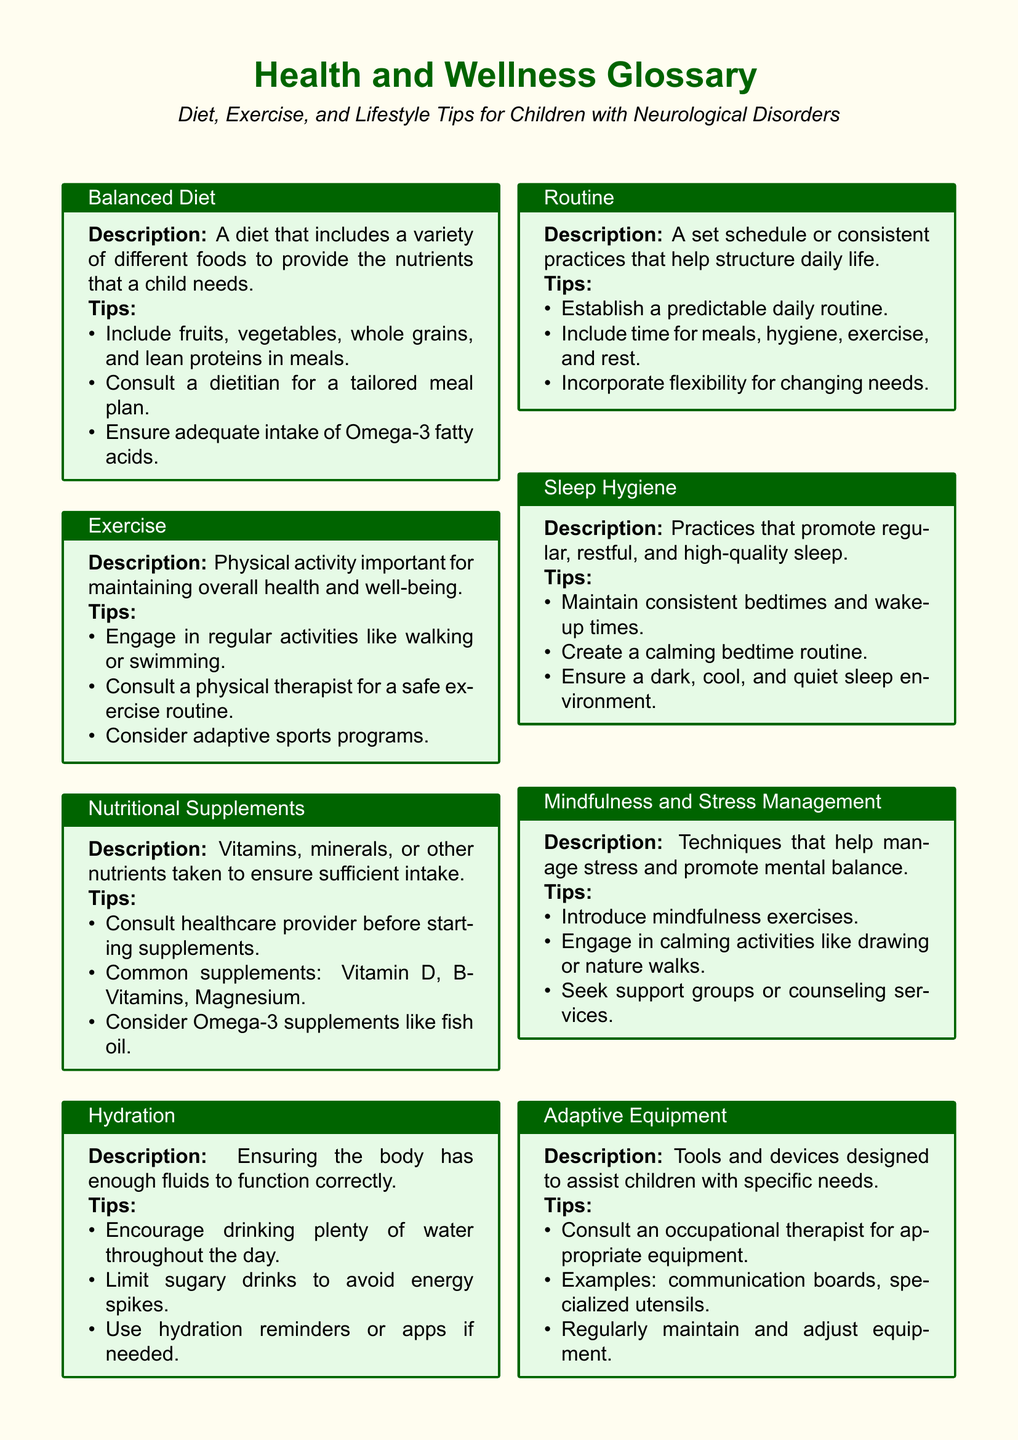What is included in a balanced diet? A balanced diet includes a variety of different foods that provide the necessary nutrients for a child.
Answer: Fruits, vegetables, whole grains, and lean proteins What is a recommended physical activity for children? The document provides examples of physical activities that can help maintain health.
Answer: Walking or swimming What should you limit to avoid energy spikes? The guidelines include suggestions for beverages appropriate for children with neurological disorders.
Answer: Sugary drinks What is an essential practice for promoting quality sleep? Sleep hygiene involves regular practices that help ensure restful sleep for children.
Answer: Consistent bedtimes and wake-up times Who should you consult before starting nutritional supplements? The advice suggests healthcare professionals that families should consult regarding diet and supplements.
Answer: Healthcare provider What is the purpose of adaptive equipment? This type of equipment is specifically designed to assist children with unique needs.
Answer: To assist children with specific needs What should be included in a daily routine? Establishing a daily routine involves scheduling consistent activities throughout the day.
Answer: Time for meals, hygiene, exercise, and rest What type of activities promote social interaction for children? The document emphasizes the importance of certain activities for enhancing children's social skills.
Answer: Tailored social activities What benefits do mindfulness exercises provide? Mindfulness practices are suggested as techniques to help manage stress.
Answer: Manage stress 